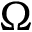Convert formula to latex. <formula><loc_0><loc_0><loc_500><loc_500>\Omega</formula> 